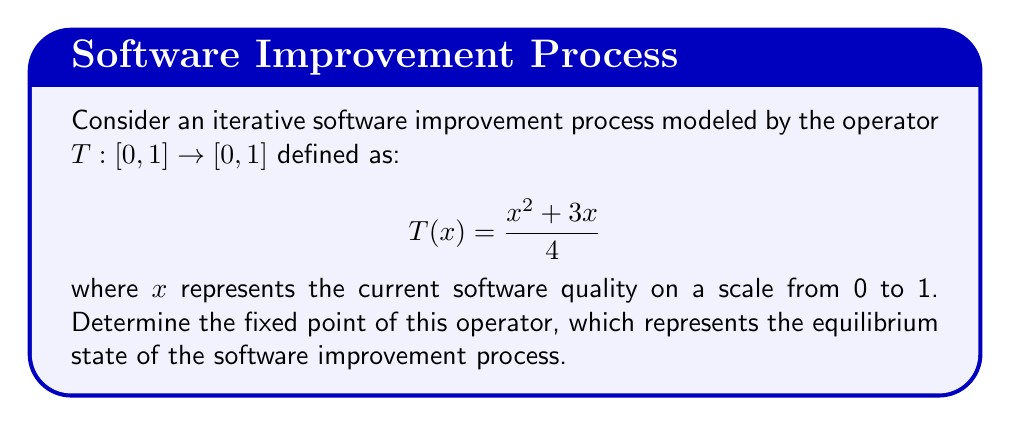What is the answer to this math problem? To solve this problem, we need to follow these steps:

1) A fixed point of an operator $T$ is a point $x^*$ such that $T(x^*) = x^*$. In other words, we need to solve the equation:

   $$x = \frac{x^2 + 3x}{4}$$

2) Multiply both sides by 4:

   $$4x = x^2 + 3x$$

3) Rearrange the equation:

   $$x^2 - x + 3x - 4x = 0$$
   $$x^2 - 2x = 0$$

4) Factor out $x$:

   $$x(x - 2) = 0$$

5) Solve this equation. The solutions are $x = 0$ or $x = 2$.

6) However, remember that our operator $T$ is defined on the interval $[0,1]$. Therefore, we need to check which of these solutions (if any) lies in this interval.

   $x = 0$ is in $[0,1]$, but $x = 2$ is not.

7) To confirm that $x = 0$ is indeed a fixed point, we can check:

   $$T(0) = \frac{0^2 + 3(0)}{4} = 0$$

Therefore, $x = 0$ is the fixed point of the operator $T$.

From a strategic perspective, this result suggests that without additional interventions, the software improvement process modeled by this operator will converge to a state of zero quality. This highlights the importance of implementing robust improvement strategies to avoid this unfavorable equilibrium.
Answer: The fixed point of the operator $T(x) = \frac{x^2 + 3x}{4}$ on the interval $[0,1]$ is $x^* = 0$. 